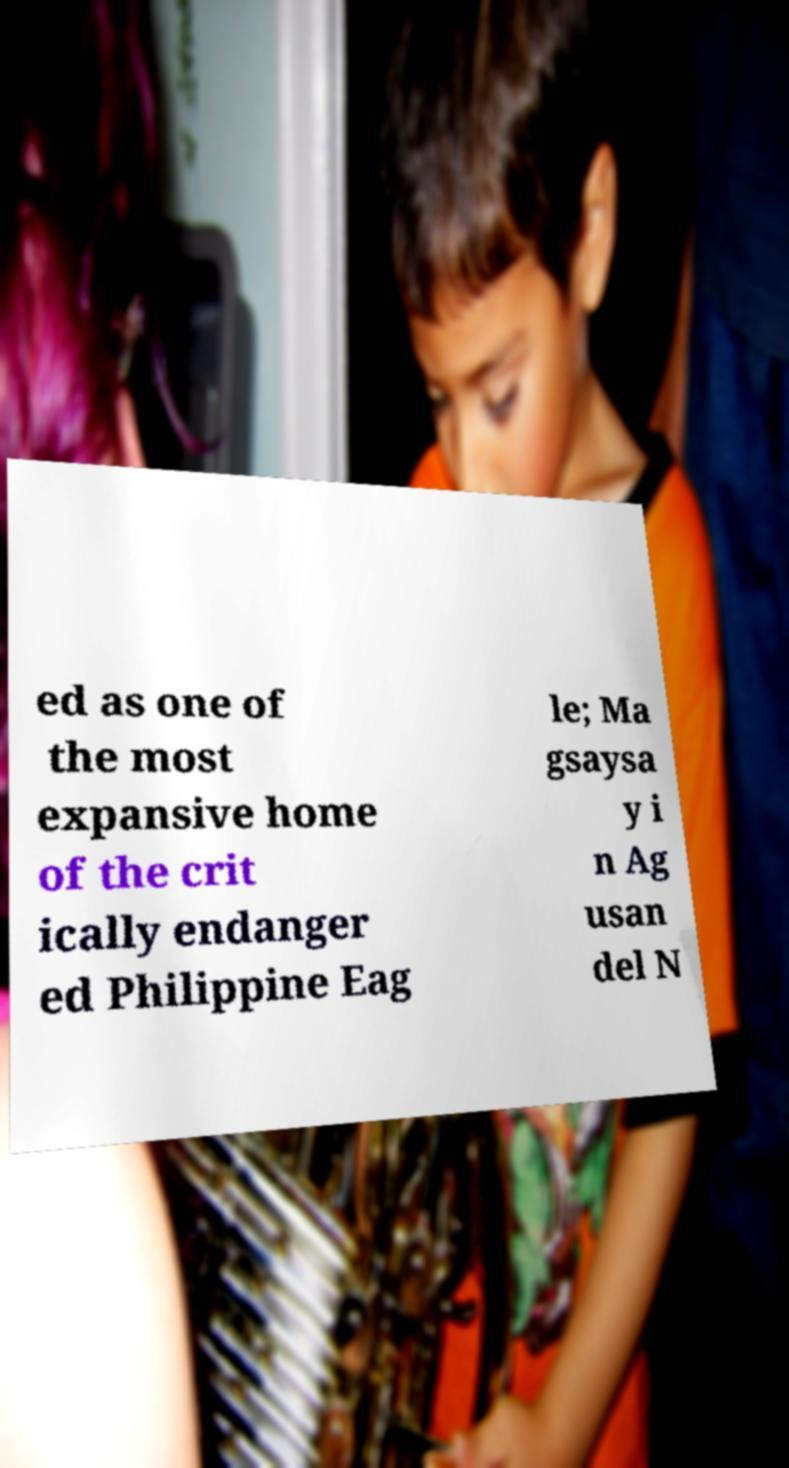I need the written content from this picture converted into text. Can you do that? ed as one of the most expansive home of the crit ically endanger ed Philippine Eag le; Ma gsaysa y i n Ag usan del N 